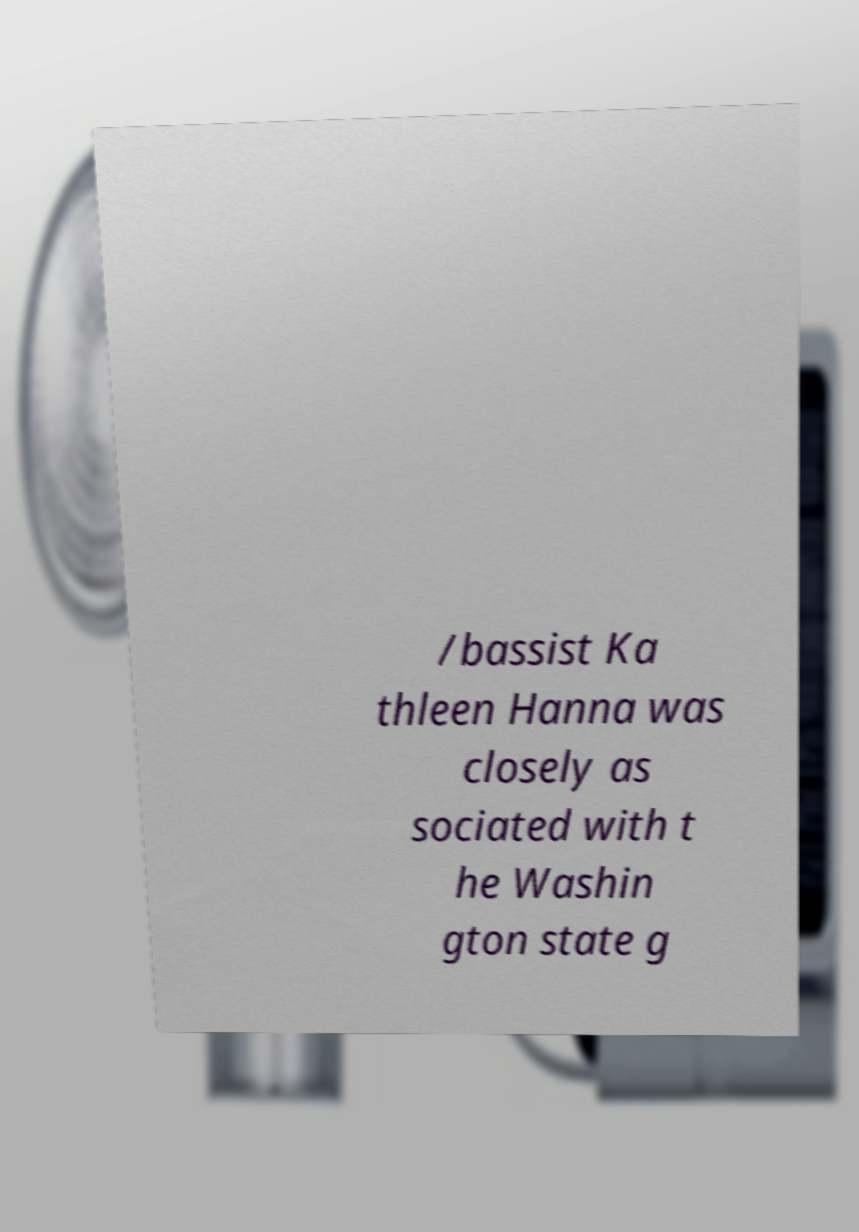Could you extract and type out the text from this image? /bassist Ka thleen Hanna was closely as sociated with t he Washin gton state g 